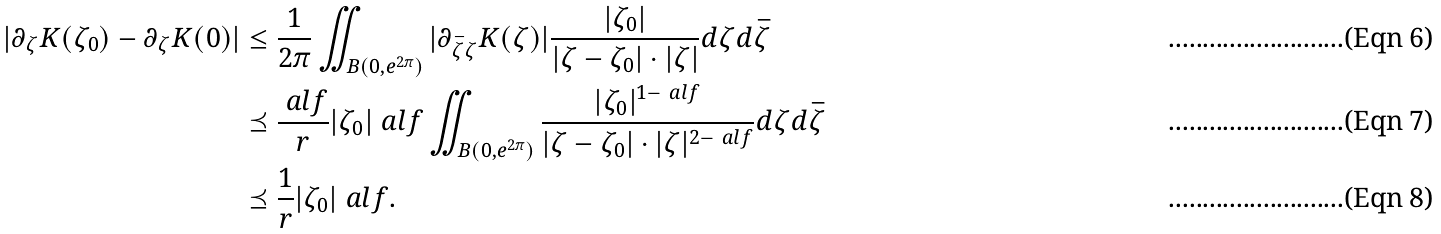<formula> <loc_0><loc_0><loc_500><loc_500>| \partial _ { \zeta } K ( \zeta _ { 0 } ) - \partial _ { \zeta } K ( 0 ) | & \leq \frac { 1 } { 2 \pi } \iint _ { B ( 0 , e ^ { 2 \pi } ) } | \partial _ { \bar { \zeta } \zeta } K ( \zeta ) | \frac { | \zeta _ { 0 } | } { | \zeta - \zeta _ { 0 } | \cdot | \zeta | } d \zeta d \bar { \zeta } \\ & \preceq \frac { \ a l f } { r } | \zeta _ { 0 } | ^ { \ } a l f \iint _ { B ( 0 , e ^ { 2 \pi } ) } \frac { | \zeta _ { 0 } | ^ { 1 - \ a l f } } { | \zeta - \zeta _ { 0 } | \cdot | \zeta | ^ { 2 - \ a l f } } d \zeta d \bar { \zeta } \\ & \preceq \frac { 1 } { r } | \zeta _ { 0 } | ^ { \ } a l f .</formula> 